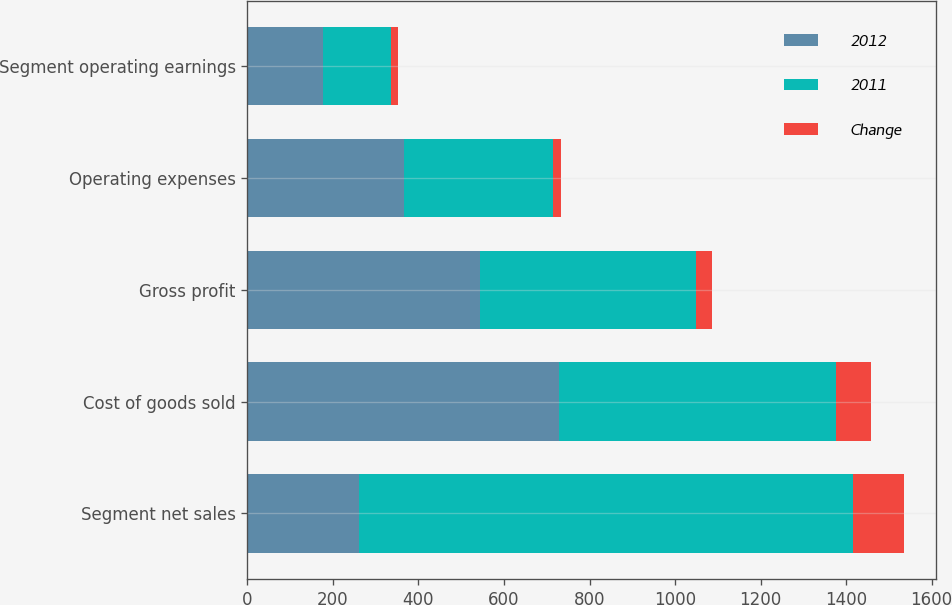<chart> <loc_0><loc_0><loc_500><loc_500><stacked_bar_chart><ecel><fcel>Segment net sales<fcel>Cost of goods sold<fcel>Gross profit<fcel>Operating expenses<fcel>Segment operating earnings<nl><fcel>2012<fcel>262.15<fcel>728.9<fcel>543.1<fcel>366.7<fcel>176.4<nl><fcel>2011<fcel>1153.4<fcel>647<fcel>506.4<fcel>347.9<fcel>158.5<nl><fcel>Change<fcel>118.6<fcel>81.9<fcel>36.7<fcel>18.8<fcel>17.9<nl></chart> 